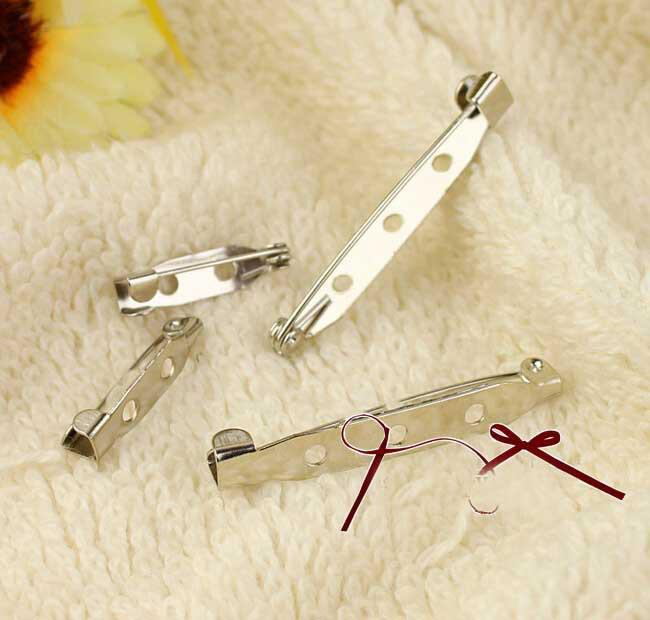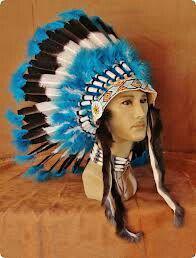The first image is the image on the left, the second image is the image on the right. Examine the images to the left and right. Is the description "Exactly one of the images contains feathers." accurate? Answer yes or no. Yes. The first image is the image on the left, the second image is the image on the right. For the images displayed, is the sentence "Left and right images show a decorative item resembling an indian headdress, and at least one of the items is made with blue beads strung on safety pins." factually correct? Answer yes or no. No. 